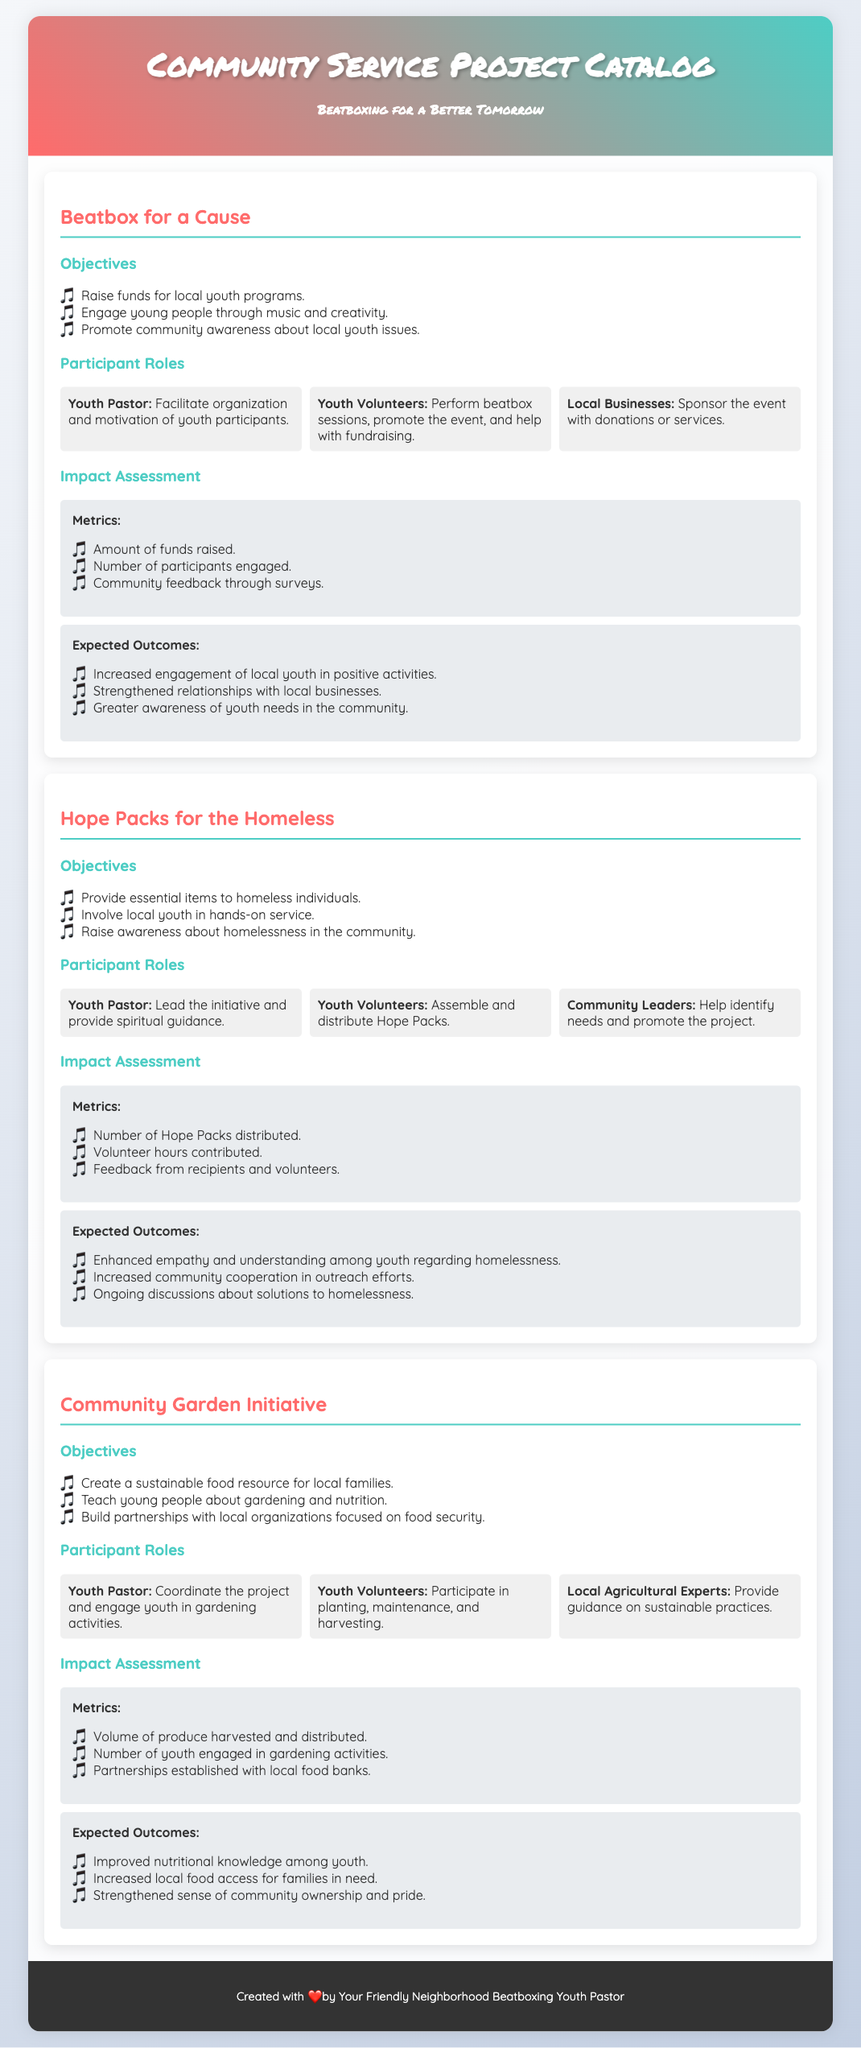what is the first project listed? The first project listed in the document is named "Beatbox for a Cause."
Answer: Beatbox for a Cause how many objectives are listed for the "Hope Packs for the Homeless" project? The document outlines three objectives for the "Hope Packs for the Homeless" project.
Answer: 3 who performs the beatbox sessions in the "Beatbox for a Cause" project? In the "Beatbox for a Cause" project, Youth Volunteers perform beatbox sessions.
Answer: Youth Volunteers what is one of the expected outcomes of the "Community Garden Initiative"? One of the expected outcomes of the "Community Garden Initiative" is improved nutritional knowledge among youth.
Answer: Improved nutritional knowledge among youth which role is responsible for identifying needs in the "Hope Packs for the Homeless" project? Community Leaders are responsible for identifying needs in the "Hope Packs for the Homeless" project.
Answer: Community Leaders how many metrics are used to assess the impact of "Beatbox for a Cause"? The impact assessment for "Beatbox for a Cause" includes three metrics.
Answer: 3 what type of experts are involved in the "Community Garden Initiative"? Local Agricultural Experts are involved in providing guidance for sustainable practices in the "Community Garden Initiative."
Answer: Local Agricultural Experts which project focuses on raising awareness about youth issues? The project that focuses on raising awareness about youth issues is "Beatbox for a Cause."
Answer: Beatbox for a Cause 